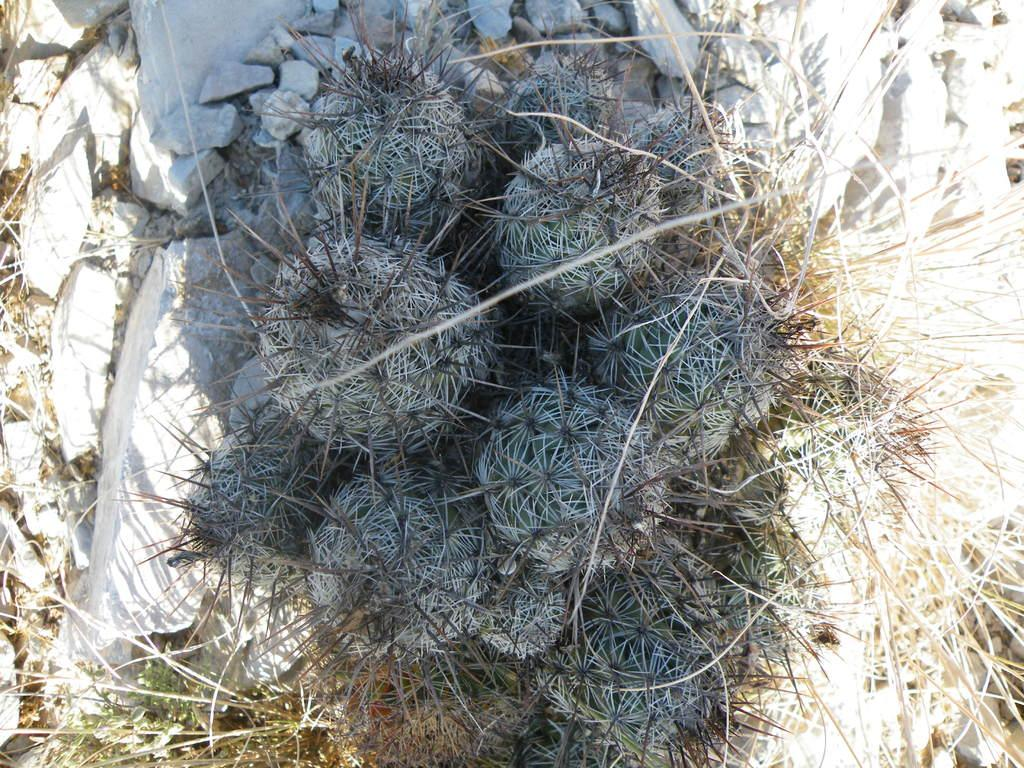What is the main subject in the center of the image? There are plants in the center of the image. What can be seen at the top side of the image? There are pebbles at the top side of the image. Where is the office located in the image? There is no office present in the image. What type of railway can be seen in the image? There is no railway present in the image. 